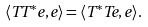Convert formula to latex. <formula><loc_0><loc_0><loc_500><loc_500>\langle T T ^ { * } e , e \rangle = \langle T ^ { * } T e , e \rangle .</formula> 